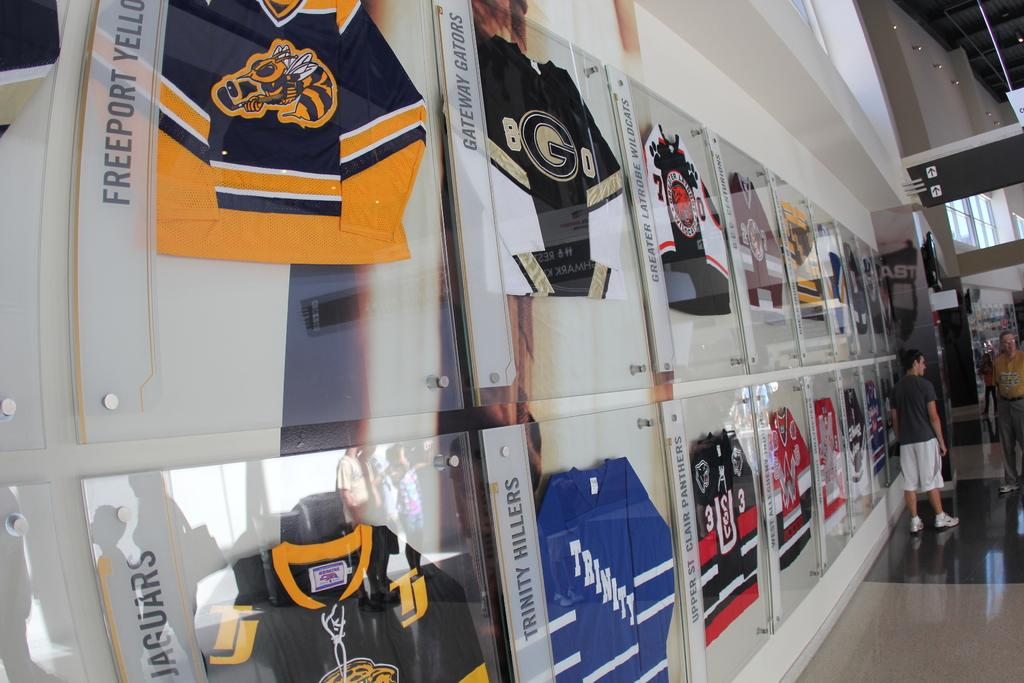<image>
Create a compact narrative representing the image presented. Jerseys for teams like the Freeport Yellowjackets and the Gateway Gators are being displayed in glass on a wall. 